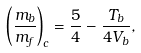Convert formula to latex. <formula><loc_0><loc_0><loc_500><loc_500>\left ( \frac { m _ { b } } { m _ { f } } \right ) _ { c } = \frac { 5 } { 4 } - \frac { T _ { b } } { 4 V _ { b } } ,</formula> 